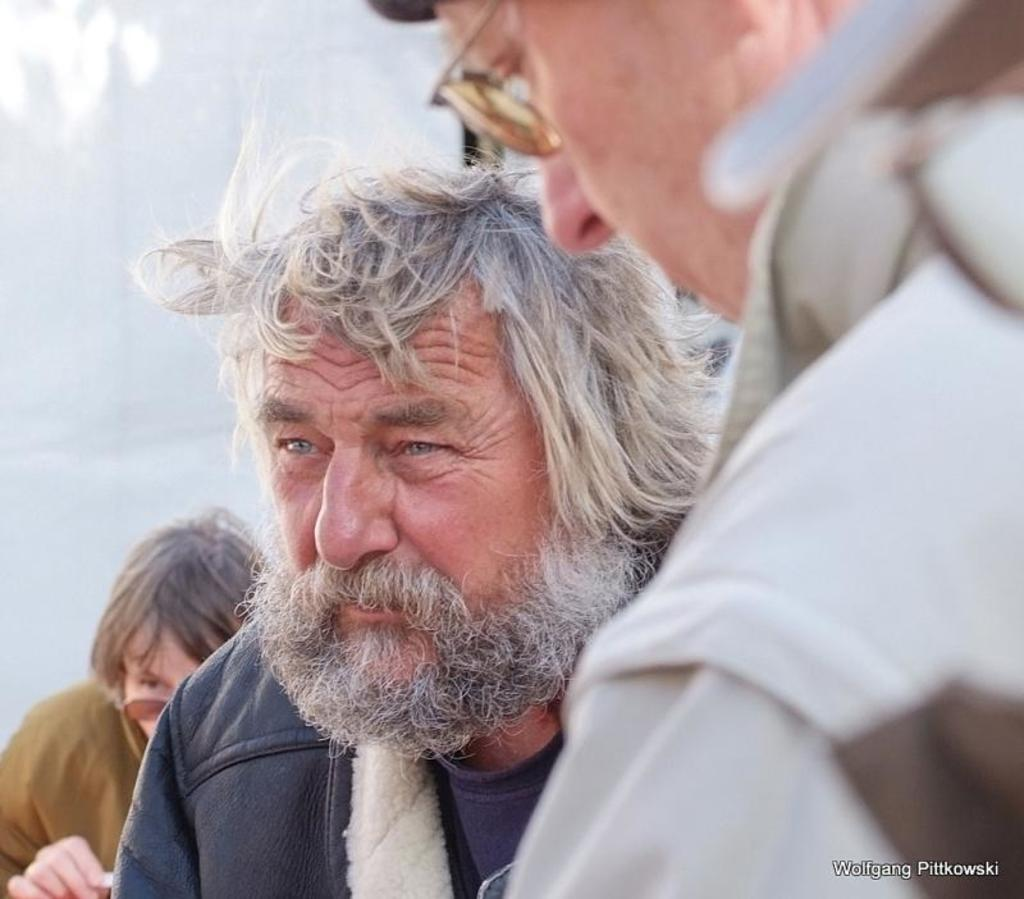Who or what is present in the image? There are people in the image. What can be found at the bottom of the image? There is text at the bottom of the image. What is visible in the background of the image? There is a wall in the background of the image. How many rings can be seen on the fingers of the people in the image? There is no information about rings or fingers in the image, so it cannot be determined. 